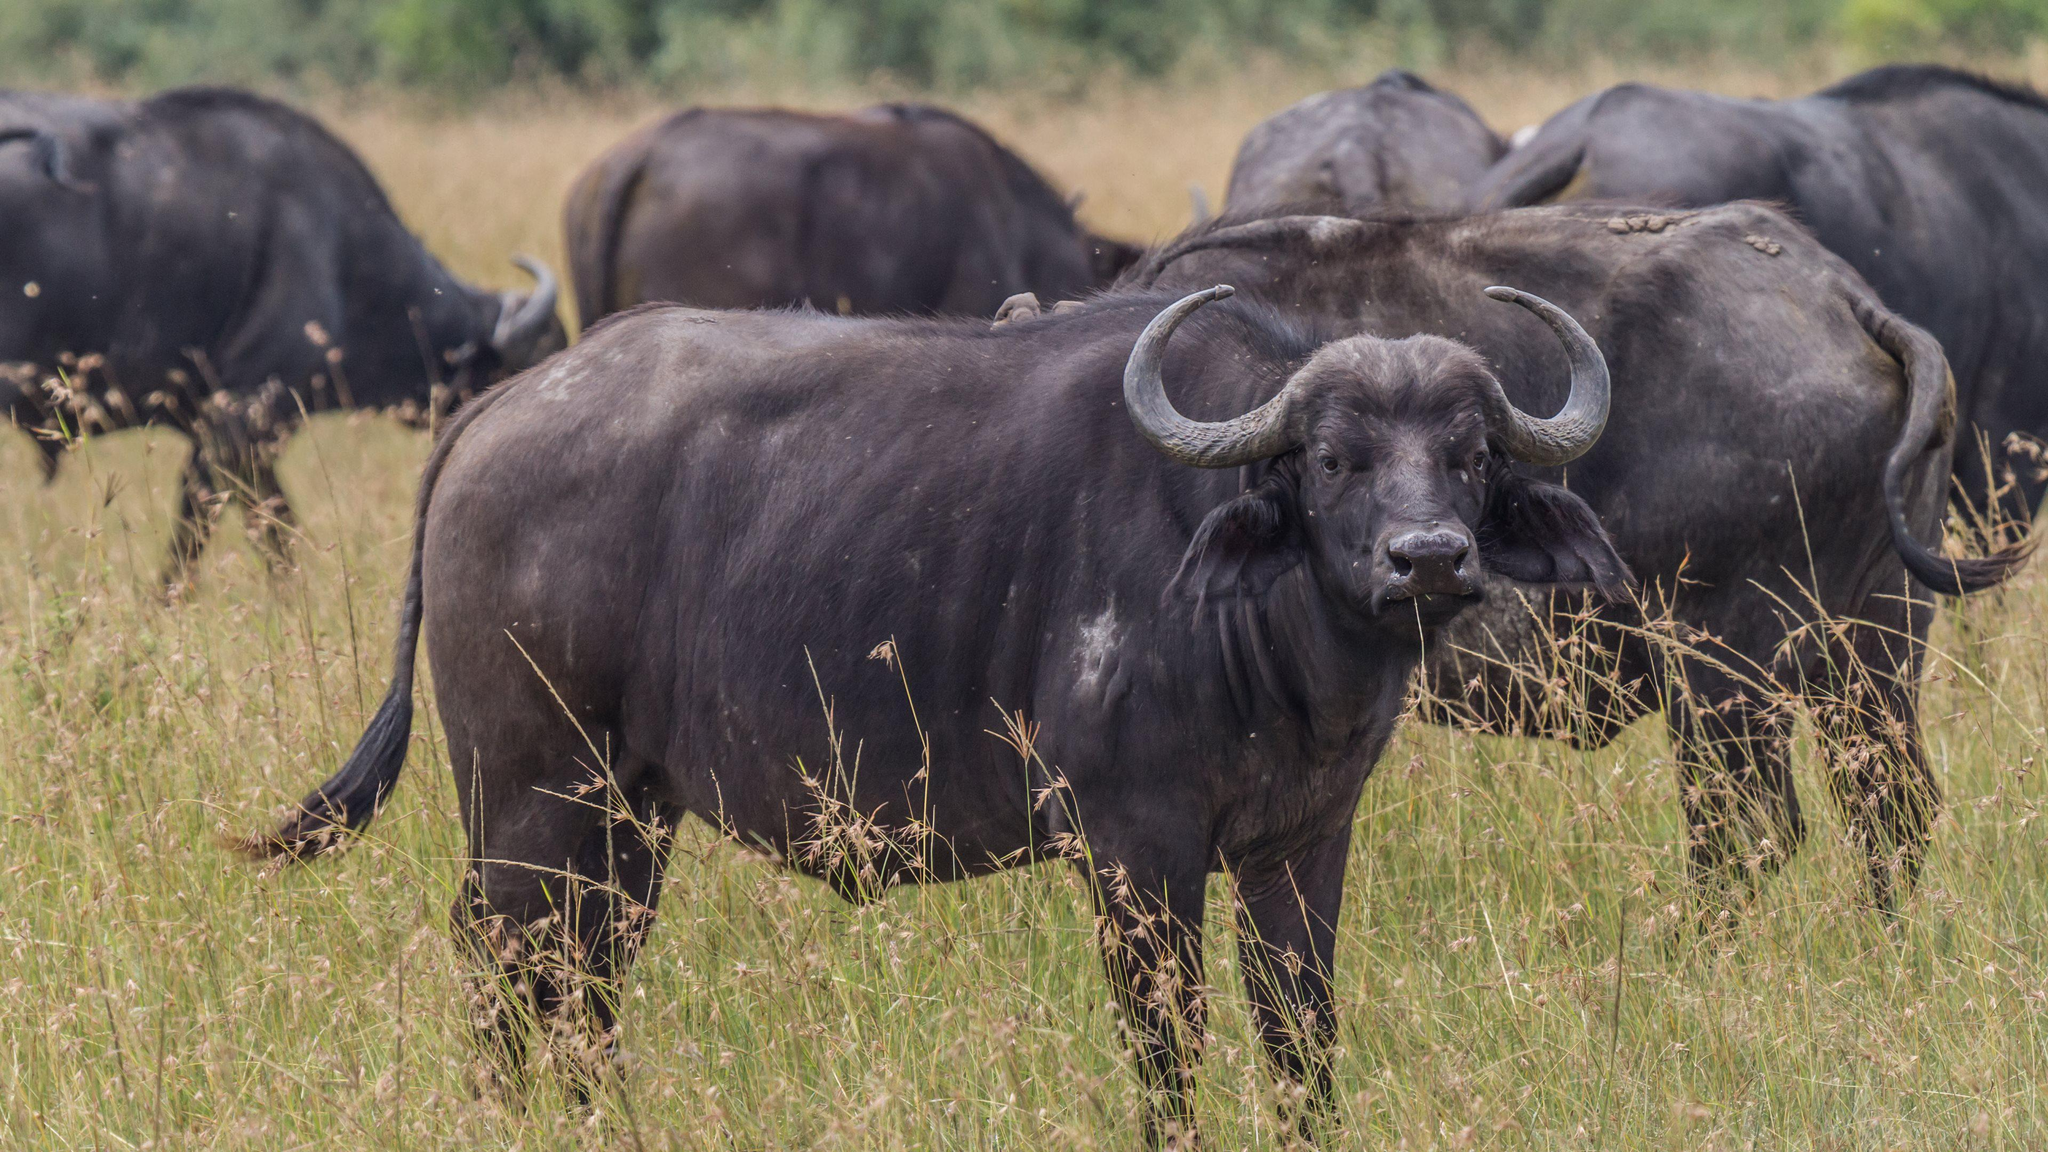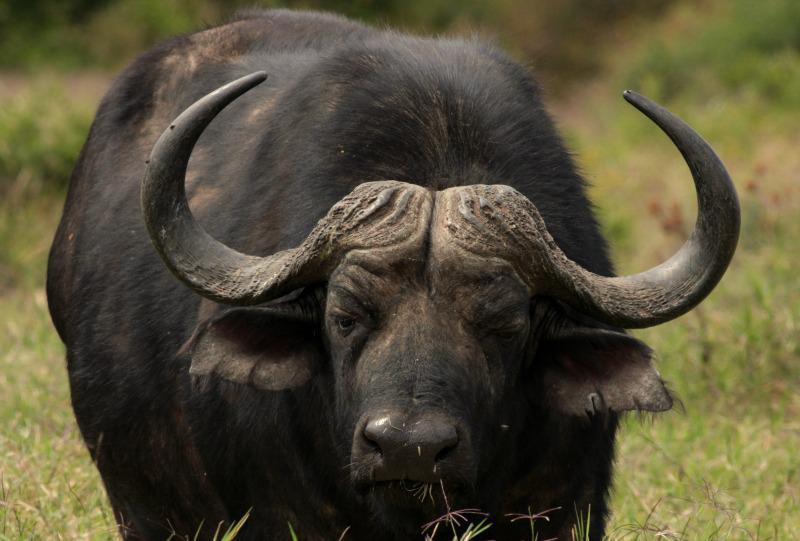The first image is the image on the left, the second image is the image on the right. For the images shown, is this caption "There is a total of 1 male African buffalo, accompanied by a total of 1 other African buffalo." true? Answer yes or no. No. The first image is the image on the left, the second image is the image on the right. For the images displayed, is the sentence "There are two buffalo." factually correct? Answer yes or no. No. 